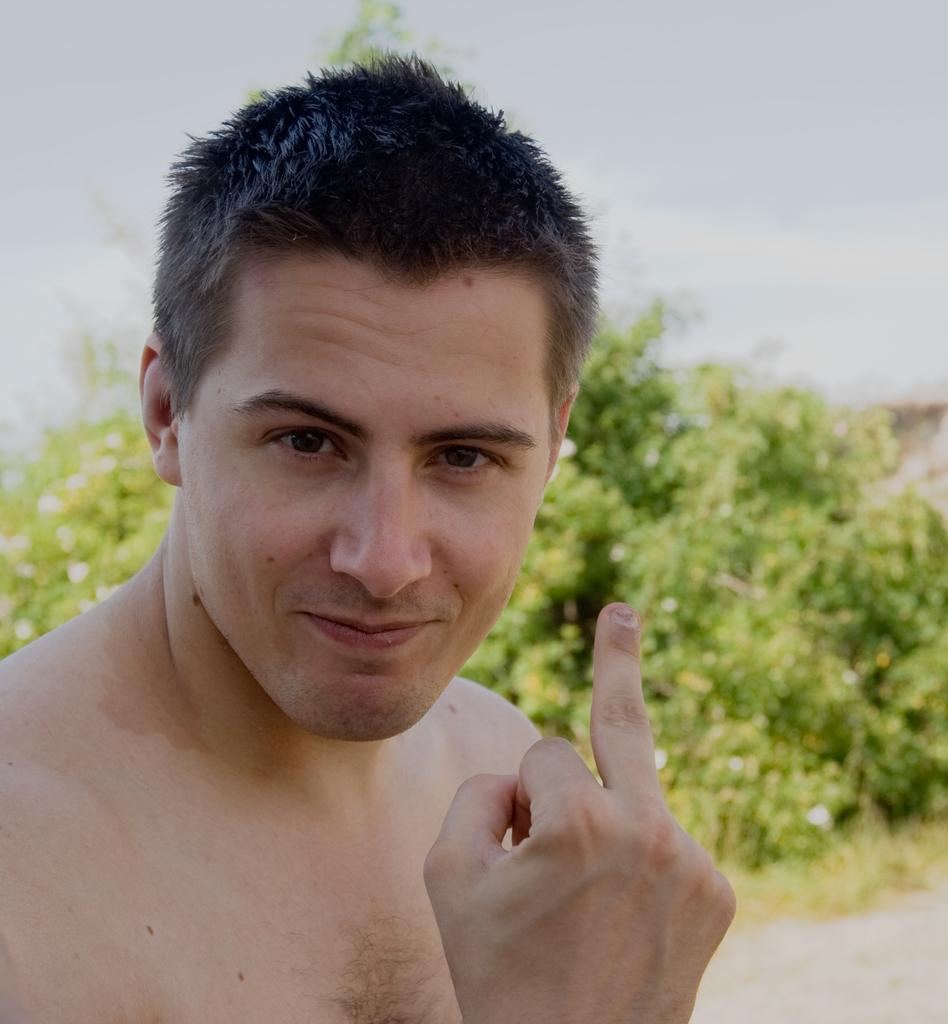Who is present in the image? There is a man in the image. What can be seen in the background of the image? There are trees behind the man in the image. How many chairs are visible in the image? There are no chairs present in the image. What type of fowl can be seen flying in the image? There is no fowl visible in the image; only a man and trees are present. 